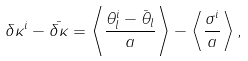<formula> <loc_0><loc_0><loc_500><loc_500>\delta \kappa ^ { i } - \bar { \delta \kappa } = \left \langle \frac { \theta _ { l } ^ { i } - \bar { \theta } _ { l } } { a } \right \rangle - \left \langle \frac { \sigma ^ { i } } { a } \right \rangle ,</formula> 